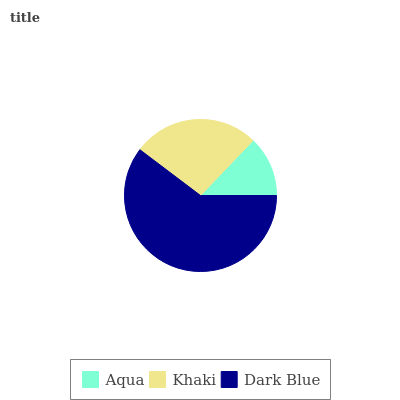Is Aqua the minimum?
Answer yes or no. Yes. Is Dark Blue the maximum?
Answer yes or no. Yes. Is Khaki the minimum?
Answer yes or no. No. Is Khaki the maximum?
Answer yes or no. No. Is Khaki greater than Aqua?
Answer yes or no. Yes. Is Aqua less than Khaki?
Answer yes or no. Yes. Is Aqua greater than Khaki?
Answer yes or no. No. Is Khaki less than Aqua?
Answer yes or no. No. Is Khaki the high median?
Answer yes or no. Yes. Is Khaki the low median?
Answer yes or no. Yes. Is Dark Blue the high median?
Answer yes or no. No. Is Dark Blue the low median?
Answer yes or no. No. 